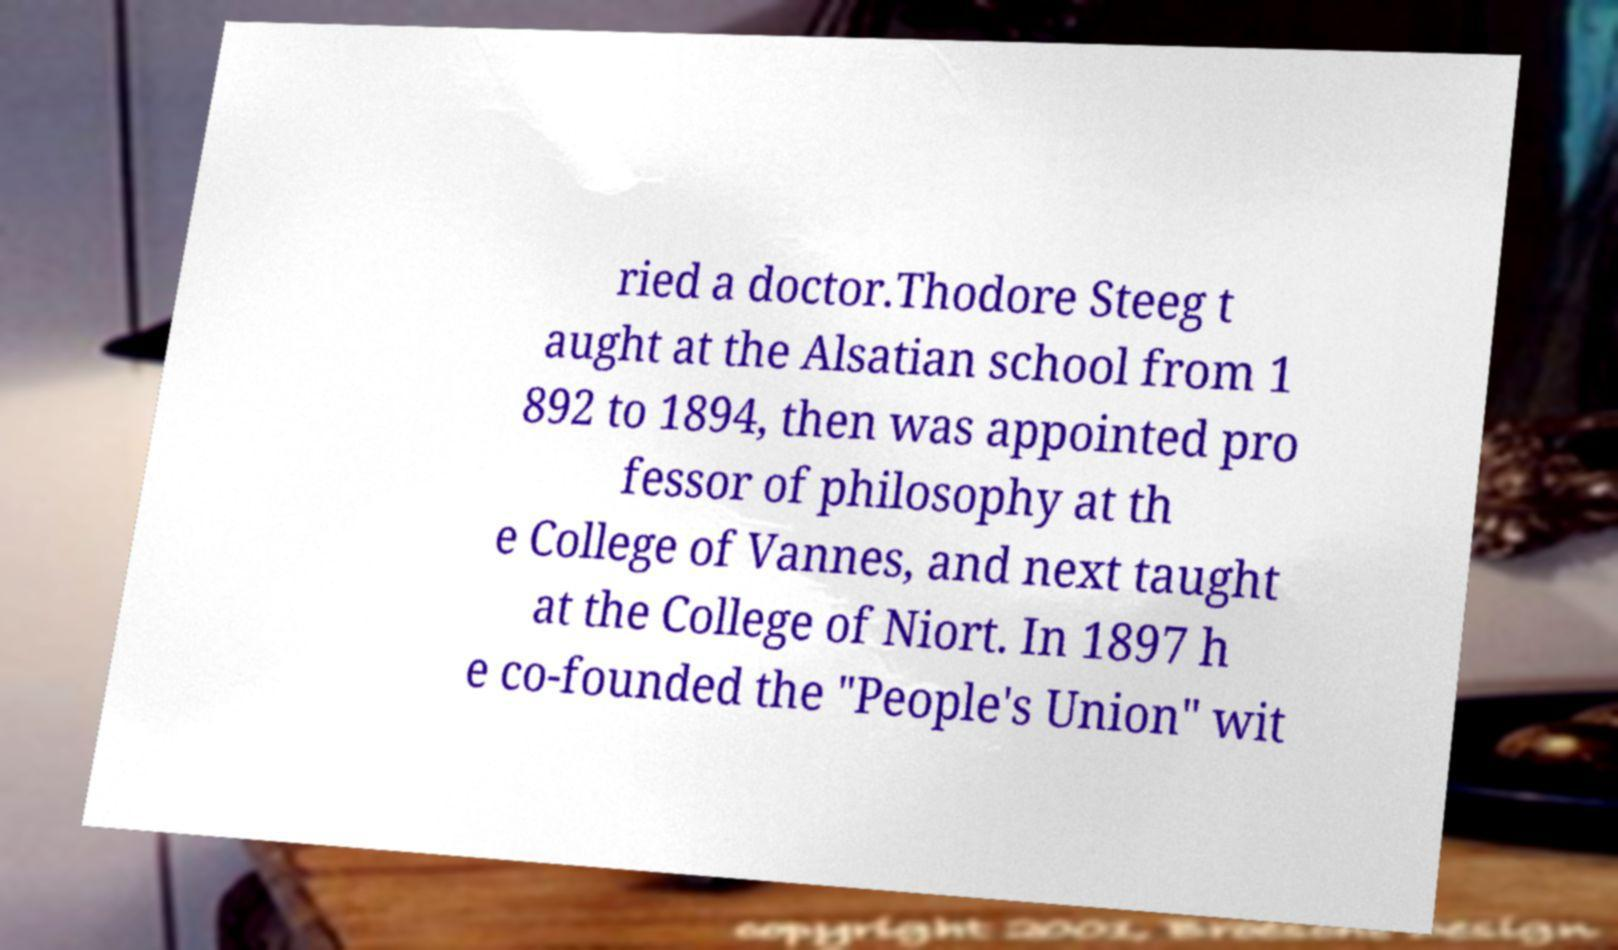Can you accurately transcribe the text from the provided image for me? ried a doctor.Thodore Steeg t aught at the Alsatian school from 1 892 to 1894, then was appointed pro fessor of philosophy at th e College of Vannes, and next taught at the College of Niort. In 1897 h e co-founded the "People's Union" wit 